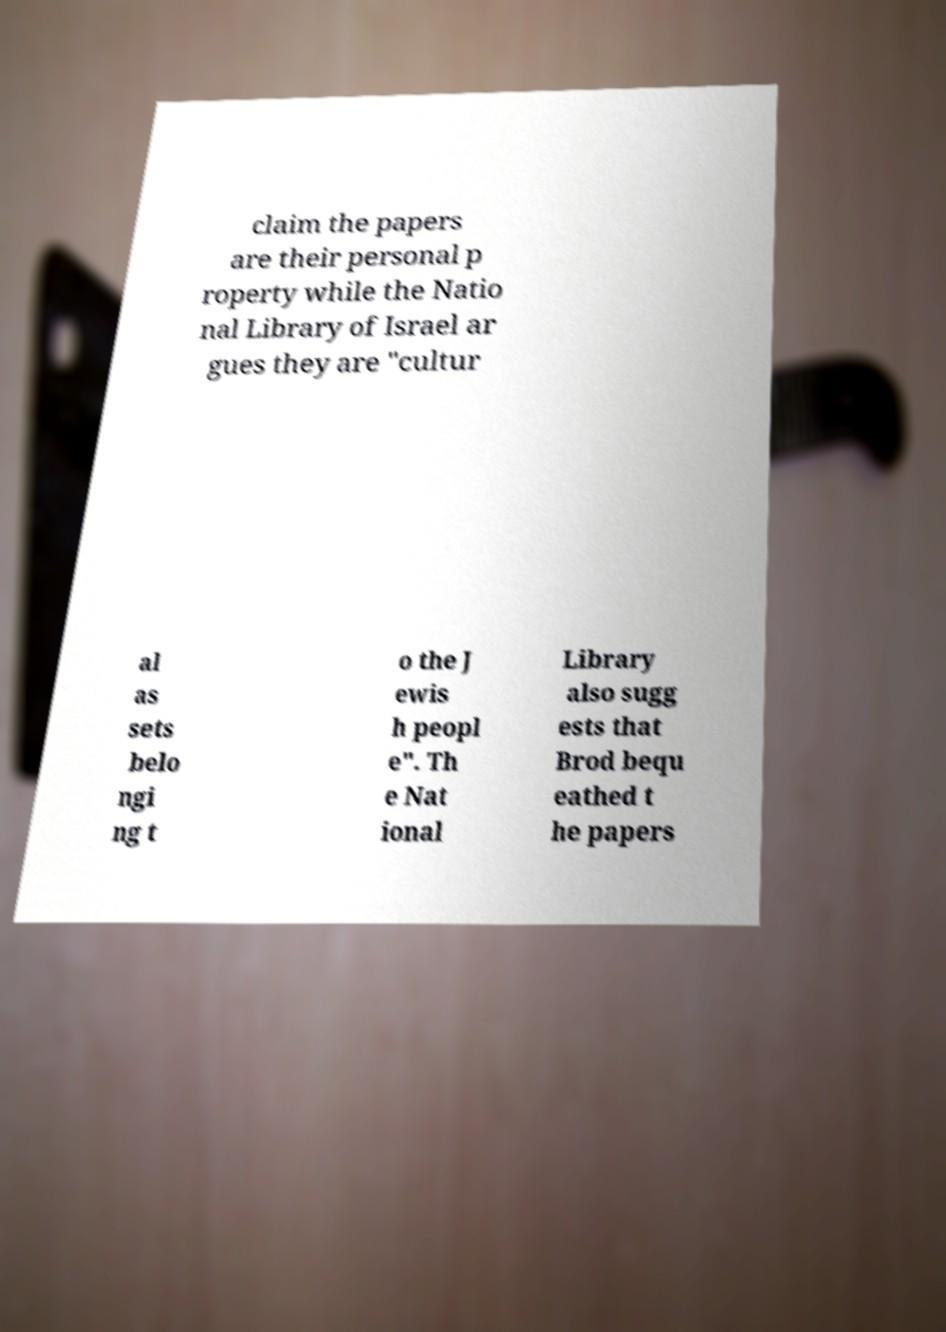Could you extract and type out the text from this image? claim the papers are their personal p roperty while the Natio nal Library of Israel ar gues they are "cultur al as sets belo ngi ng t o the J ewis h peopl e". Th e Nat ional Library also sugg ests that Brod bequ eathed t he papers 